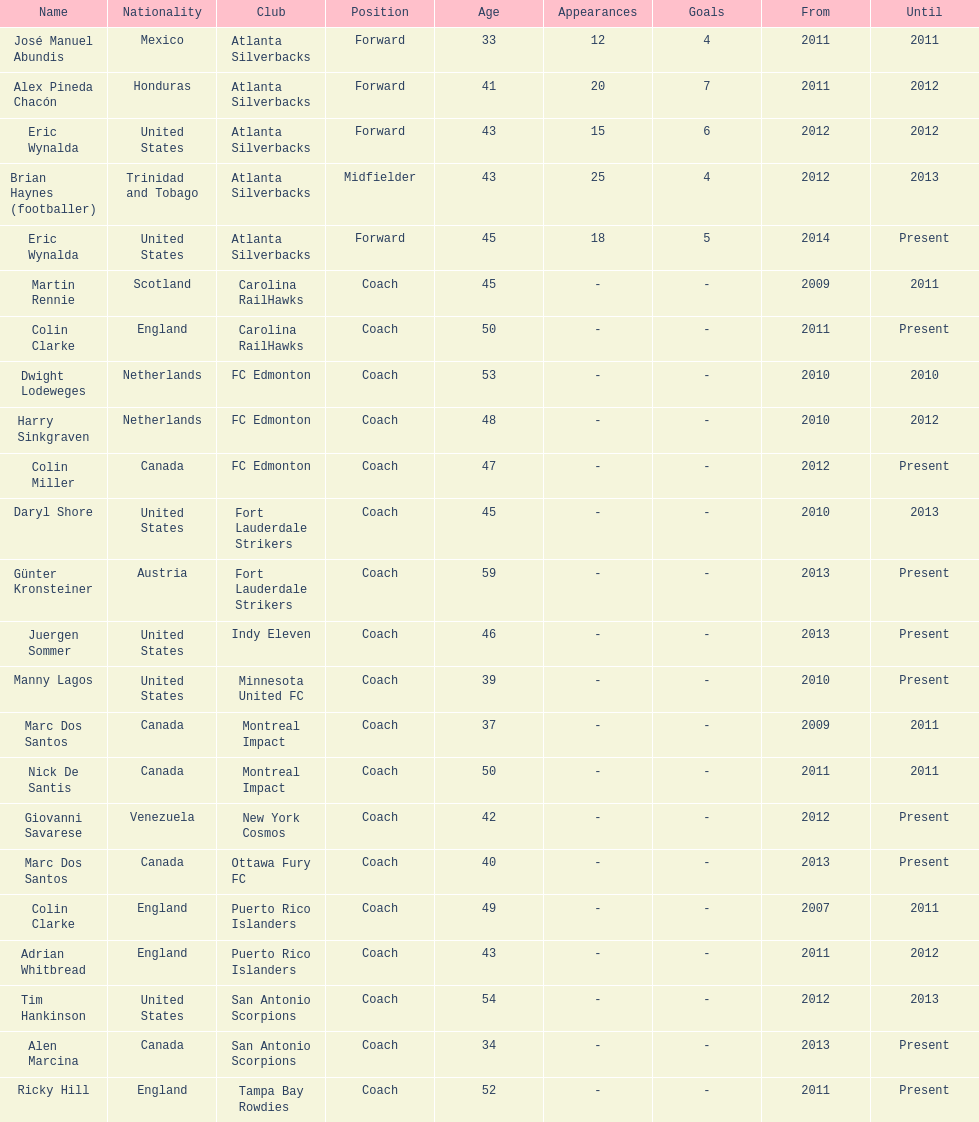How long did colin clarke coach the puerto rico islanders for? 4 years. 